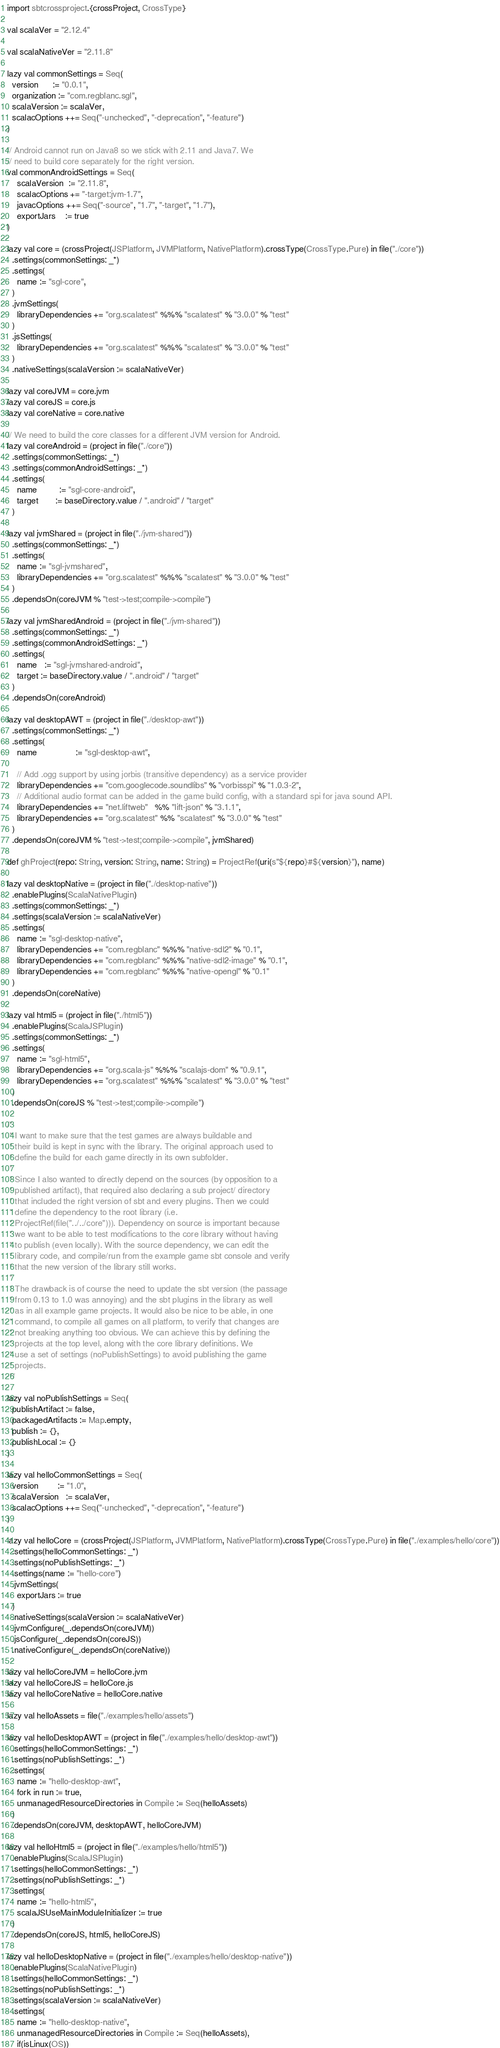<code> <loc_0><loc_0><loc_500><loc_500><_Scala_>import sbtcrossproject.{crossProject, CrossType}

val scalaVer = "2.12.4"

val scalaNativeVer = "2.11.8"

lazy val commonSettings = Seq(
  version      := "0.0.1",
  organization := "com.regblanc.sgl",
  scalaVersion := scalaVer,
  scalacOptions ++= Seq("-unchecked", "-deprecation", "-feature")
)

// Android cannot run on Java8 so we stick with 2.11 and Java7. We
// need to build core separately for the right version.
val commonAndroidSettings = Seq(
    scalaVersion  := "2.11.8",
    scalacOptions += "-target:jvm-1.7",
    javacOptions ++= Seq("-source", "1.7", "-target", "1.7"),
    exportJars    := true
)

lazy val core = (crossProject(JSPlatform, JVMPlatform, NativePlatform).crossType(CrossType.Pure) in file("./core"))
  .settings(commonSettings: _*)
  .settings(
    name := "sgl-core",
  )
  .jvmSettings(
    libraryDependencies += "org.scalatest" %%% "scalatest" % "3.0.0" % "test"
  )
  .jsSettings(
    libraryDependencies += "org.scalatest" %%% "scalatest" % "3.0.0" % "test"
  )
  .nativeSettings(scalaVersion := scalaNativeVer)

lazy val coreJVM = core.jvm
lazy val coreJS = core.js
lazy val coreNative = core.native

// We need to build the core classes for a different JVM version for Android.
lazy val coreAndroid = (project in file("./core"))
  .settings(commonSettings: _*)
  .settings(commonAndroidSettings: _*)
  .settings(
    name         := "sgl-core-android",
    target       := baseDirectory.value / ".android" / "target"
  )

lazy val jvmShared = (project in file("./jvm-shared"))
  .settings(commonSettings: _*)
  .settings(
    name := "sgl-jvmshared",
    libraryDependencies += "org.scalatest" %%% "scalatest" % "3.0.0" % "test"
  )
  .dependsOn(coreJVM % "test->test;compile->compile")

lazy val jvmSharedAndroid = (project in file("./jvm-shared"))
  .settings(commonSettings: _*)
  .settings(commonAndroidSettings: _*)
  .settings(
    name   := "sgl-jvmshared-android",
    target := baseDirectory.value / ".android" / "target"
  )
  .dependsOn(coreAndroid)

lazy val desktopAWT = (project in file("./desktop-awt"))
  .settings(commonSettings: _*)
  .settings(
    name                := "sgl-desktop-awt",

    // Add .ogg support by using jorbis (transitive dependency) as a service provider
    libraryDependencies += "com.googlecode.soundlibs" % "vorbisspi" % "1.0.3-2", 
    // Additional audio format can be added in the game build config, with a standard spi for java sound API.
    libraryDependencies += "net.liftweb"   %% "lift-json" % "3.1.1",
    libraryDependencies += "org.scalatest" %% "scalatest" % "3.0.0" % "test"
  )
  .dependsOn(coreJVM % "test->test;compile->compile", jvmShared)

def ghProject(repo: String, version: String, name: String) = ProjectRef(uri(s"${repo}#${version}"), name)

lazy val desktopNative = (project in file("./desktop-native"))
  .enablePlugins(ScalaNativePlugin)
  .settings(commonSettings: _*)
  .settings(scalaVersion := scalaNativeVer)
  .settings(
    name := "sgl-desktop-native",
    libraryDependencies += "com.regblanc" %%% "native-sdl2" % "0.1",
    libraryDependencies += "com.regblanc" %%% "native-sdl2-image" % "0.1",
    libraryDependencies += "com.regblanc" %%% "native-opengl" % "0.1"
  )
  .dependsOn(coreNative)

lazy val html5 = (project in file("./html5"))
  .enablePlugins(ScalaJSPlugin)
  .settings(commonSettings: _*)
  .settings(
    name := "sgl-html5",
    libraryDependencies += "org.scala-js" %%% "scalajs-dom" % "0.9.1",
    libraryDependencies += "org.scalatest" %%% "scalatest" % "3.0.0" % "test"
  )
  .dependsOn(coreJS % "test->test;compile->compile")

/*
 * I want to make sure that the test games are always buildable and
 * their build is kept in sync with the library. The original approach used to 
 * define the build for each game directly in its own subfolder.
 * 
 * Since I also wanted to directly depend on the sources (by opposition to a
 * published artifact), that required also declaring a sub project/ directory
 * that included the right version of sbt and every plugins. Then we could
 * define the dependency to the root library (i.e. 
 * ProjectRef(file("../../core"))). Dependency on source is important because
 * we want to be able to test modifications to the core library without having
 * to publish (even locally). With the source dependency, we can edit the
 * library code, and compile/run from the example game sbt console and verify
 * that the new version of the library still works.
 *
 * The drawback is of course the need to update the sbt version (the passage
 * from 0.13 to 1.0 was annoying) and the sbt plugins in the library as well
 * as in all example game projects. It would also be nice to be able, in one
 * command, to compile all games on all platform, to verify that changes are
 * not breaking anything too obvious. We can achieve this by defining the
 * projects at the top level, along with the core library definitions. We
 * use a set of settings (noPublishSettings) to avoid publishing the game
 * projects.
 */

lazy val noPublishSettings = Seq(
  publishArtifact := false,
  packagedArtifacts := Map.empty,
  publish := {},
  publishLocal := {}
)

lazy val helloCommonSettings = Seq(
  version        := "1.0",
  scalaVersion   := scalaVer,
  scalacOptions ++= Seq("-unchecked", "-deprecation", "-feature")
)

lazy val helloCore = (crossProject(JSPlatform, JVMPlatform, NativePlatform).crossType(CrossType.Pure) in file("./examples/hello/core"))
  .settings(helloCommonSettings: _*)
  .settings(noPublishSettings: _*)
  .settings(name := "hello-core")
  .jvmSettings(
    exportJars := true
  )
  .nativeSettings(scalaVersion := scalaNativeVer)
  .jvmConfigure(_.dependsOn(coreJVM))
  .jsConfigure(_.dependsOn(coreJS))
  .nativeConfigure(_.dependsOn(coreNative))

lazy val helloCoreJVM = helloCore.jvm
lazy val helloCoreJS = helloCore.js
lazy val helloCoreNative = helloCore.native

lazy val helloAssets = file("./examples/hello/assets")

lazy val helloDesktopAWT = (project in file("./examples/hello/desktop-awt"))
  .settings(helloCommonSettings: _*)
  .settings(noPublishSettings: _*)
  .settings(
    name := "hello-desktop-awt",
    fork in run := true,
    unmanagedResourceDirectories in Compile := Seq(helloAssets)
  )
  .dependsOn(coreJVM, desktopAWT, helloCoreJVM)

lazy val helloHtml5 = (project in file("./examples/hello/html5"))
  .enablePlugins(ScalaJSPlugin)
  .settings(helloCommonSettings: _*)
  .settings(noPublishSettings: _*)
  .settings(
    name := "hello-html5",
    scalaJSUseMainModuleInitializer := true
  )
  .dependsOn(coreJS, html5, helloCoreJS)

lazy val helloDesktopNative = (project in file("./examples/hello/desktop-native"))
  .enablePlugins(ScalaNativePlugin)
  .settings(helloCommonSettings: _*)
  .settings(noPublishSettings: _*)
  .settings(scalaVersion := scalaNativeVer)
  .settings(
    name := "hello-desktop-native",
    unmanagedResourceDirectories in Compile := Seq(helloAssets),
    if(isLinux(OS))</code> 